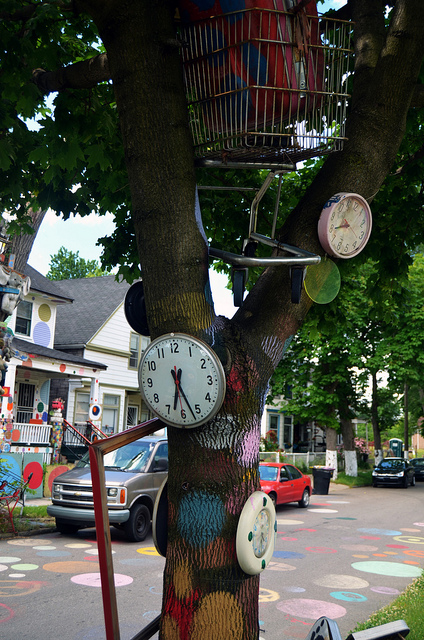Identify and read out the text in this image. 12 3 8 10 11 7 8 5 4 3 2 1 12 9 7 6 5 4 2 1" 